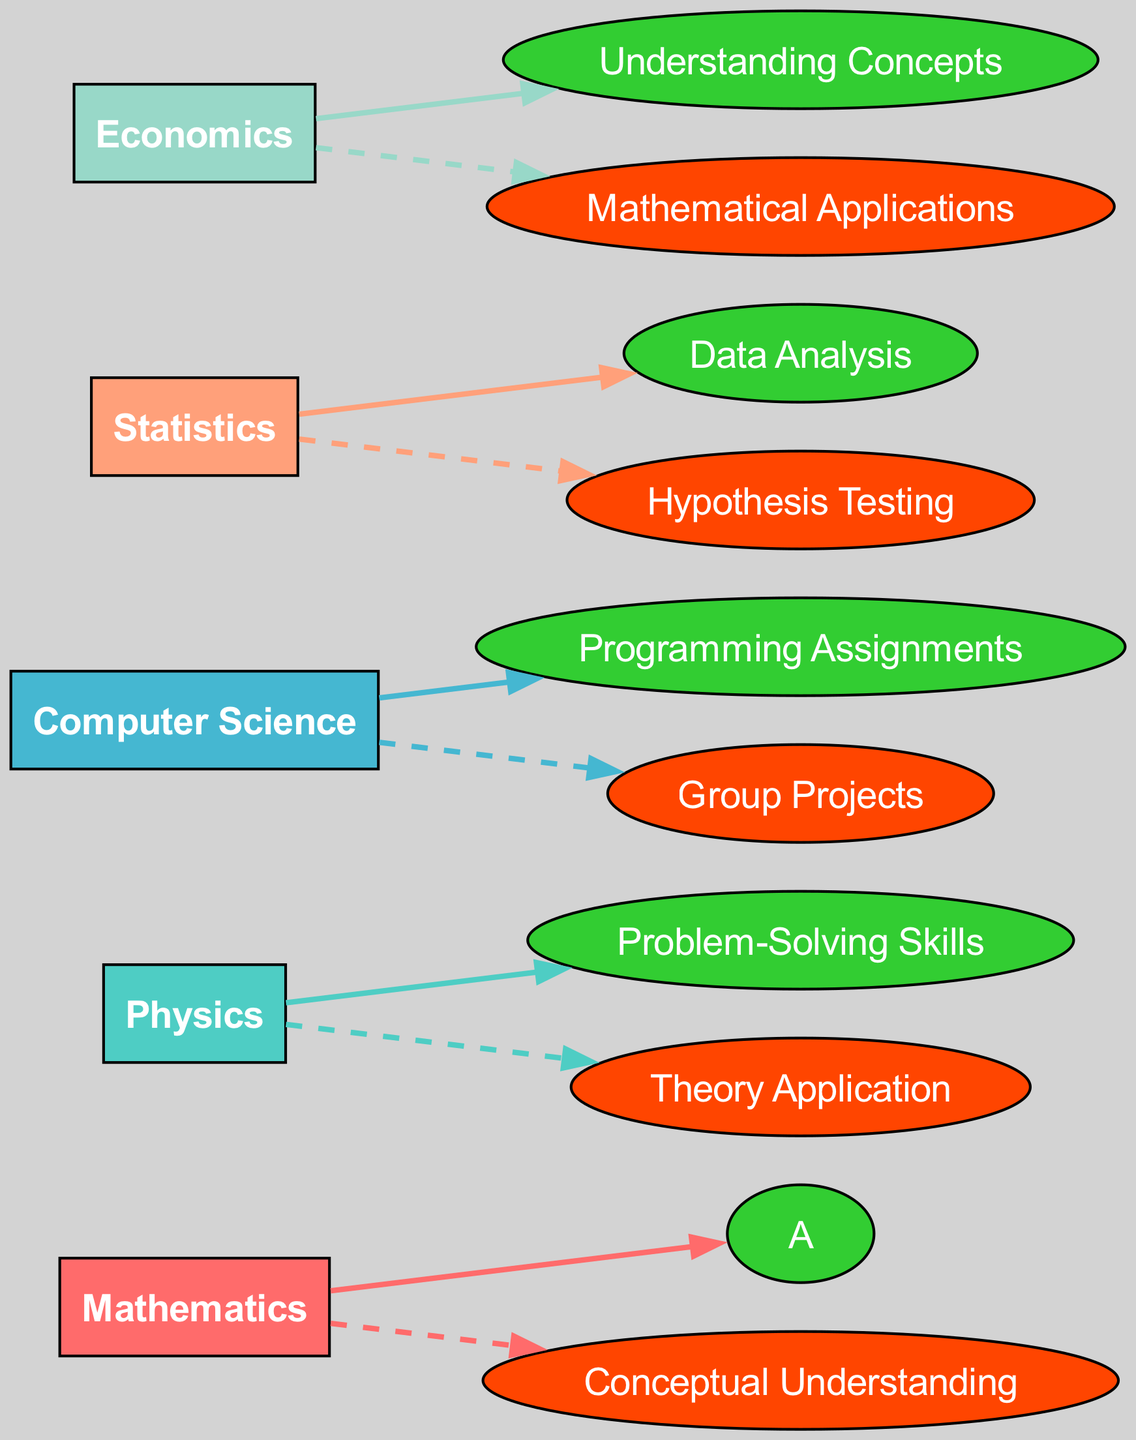What are the strengths indicated in the diagram? The strengths are mentioned directly in the performance section of each subject. The strengths are: A, Problem-Solving Skills, Programming Assignments, Data Analysis, and Understanding Concepts.
Answer: A, Problem-Solving Skills, Programming Assignments, Data Analysis, Understanding Concepts Which subject has the weakness in Conceptual Understanding? By checking each subject’s performance section, Mathematics is the subject that lists Conceptual Understanding as its weakness.
Answer: Mathematics How many subjects are represented in the diagram? The number of subjects can be counted from the nodes created for each academic subject in the diagram. There are 5 subjects present in the diagram.
Answer: 5 Which subject shows a weakness related to Mathematical Applications? The weakness related to Mathematical Applications can be found in the Economics subject performance section.
Answer: Economics What type of flow is shown from the subjects to their weaknesses? The flow from the subjects to their weaknesses is shown with a dashed line, indicating a weaker connection or performance.
Answer: Dashed line Which subject has the strongest performance in Data Analysis? The subject that has the strongest performance in Data Analysis is Statistics, as indicated in its performance section.
Answer: Statistics Identify the subject that exhibits strong Programming Assignments capability. The subject that exhibits strong capability in Programming Assignments is Computer Science, as seen in its performance section.
Answer: Computer Science How many total weaknesses are identified in the diagram? By examining each subject’s weaknesses, there are a total of 5 weaknesses identified: Conceptual Understanding, Theory Application, Group Projects, Hypothesis Testing, and Mathematical Applications.
Answer: 5 What is the relationship type between Physics and its weaknesses? The relationship type between Physics and its weaknesses is shown by a dashed line indicating a weaker performance linkage with Theory Application.
Answer: Dashed line 